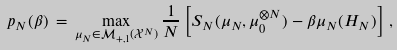Convert formula to latex. <formula><loc_0><loc_0><loc_500><loc_500>p _ { N } ( \beta ) \, = \, \max _ { \mu _ { N } \in \mathcal { M } _ { + , 1 } ( \mathcal { X } ^ { N } ) } \frac { 1 } { N } \left [ S _ { N } ( \mu _ { N } , \mu _ { 0 } ^ { \otimes N } ) - \beta \mu _ { N } ( H _ { N } ) \right ] \, ,</formula> 